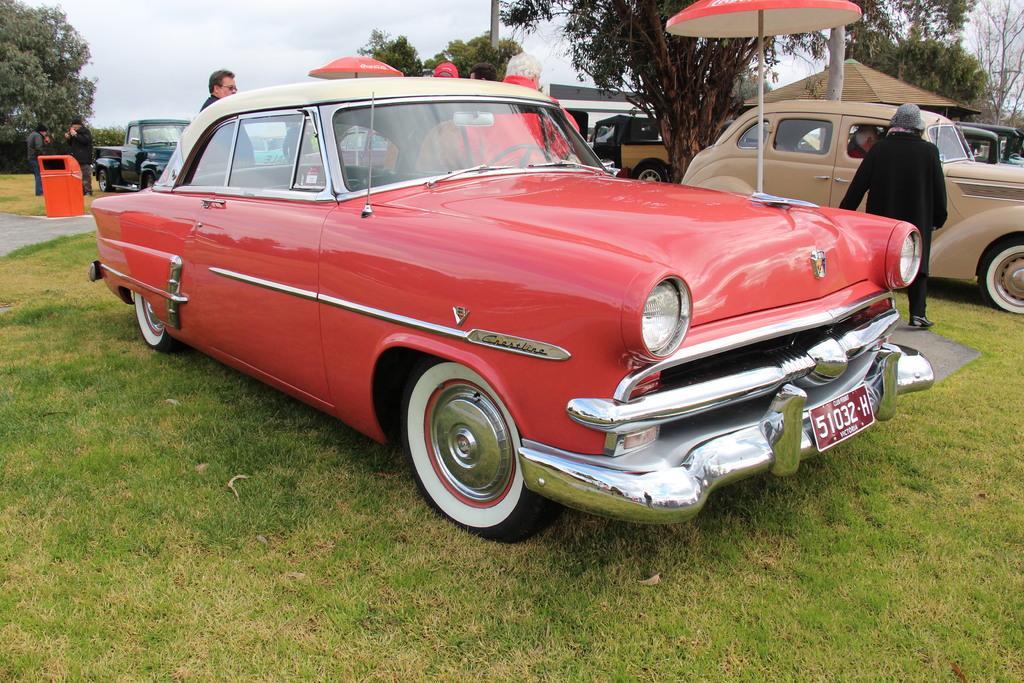How would you summarize this image in a sentence or two? In this picture, we can see a few vehicles, a few people, ground with grass, poles, umbrella, trees, path, trash bin, and the sky. 